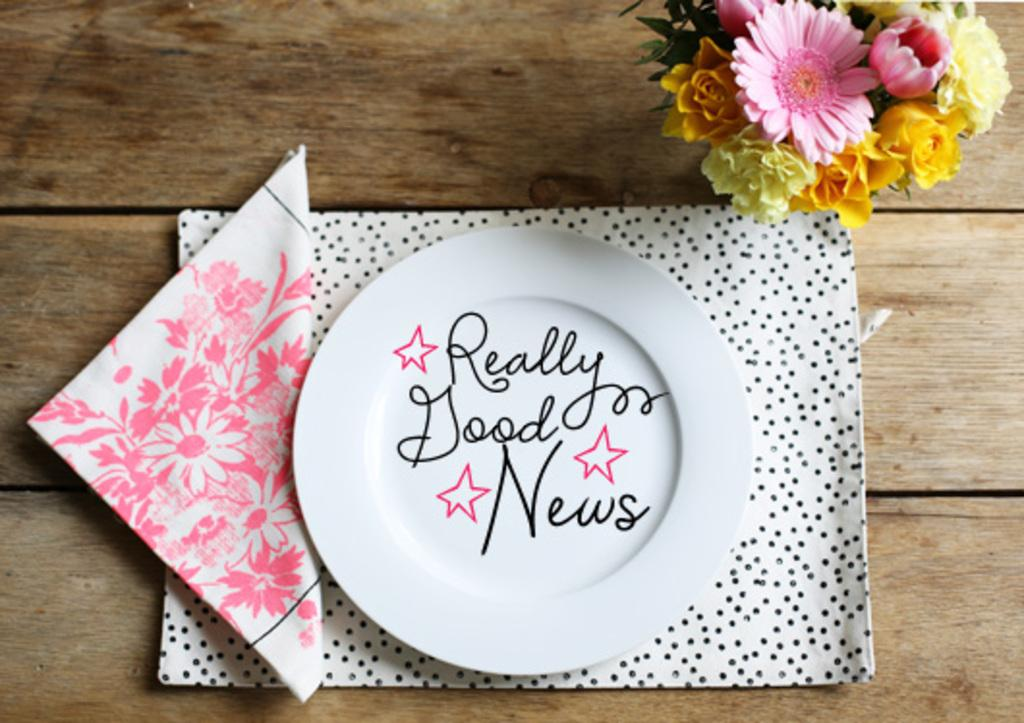Provide a one-sentence caption for the provided image. a white plate that says Really Good News on it. 